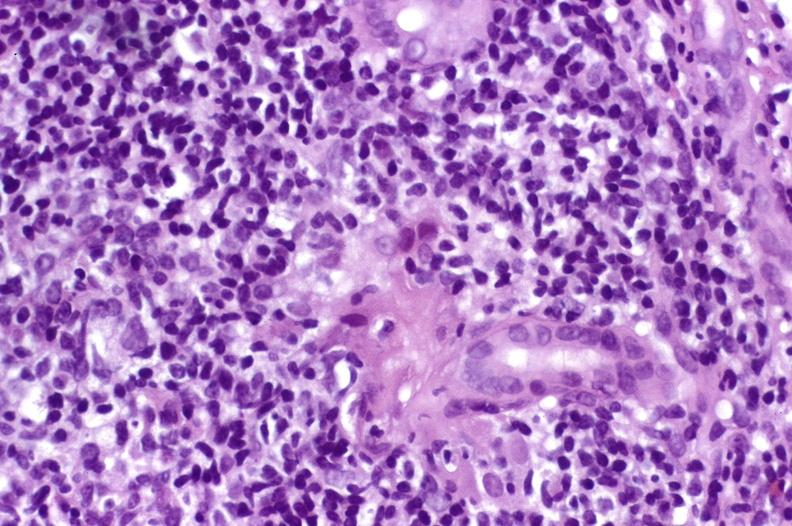what is present?
Answer the question using a single word or phrase. Hepatobiliary 